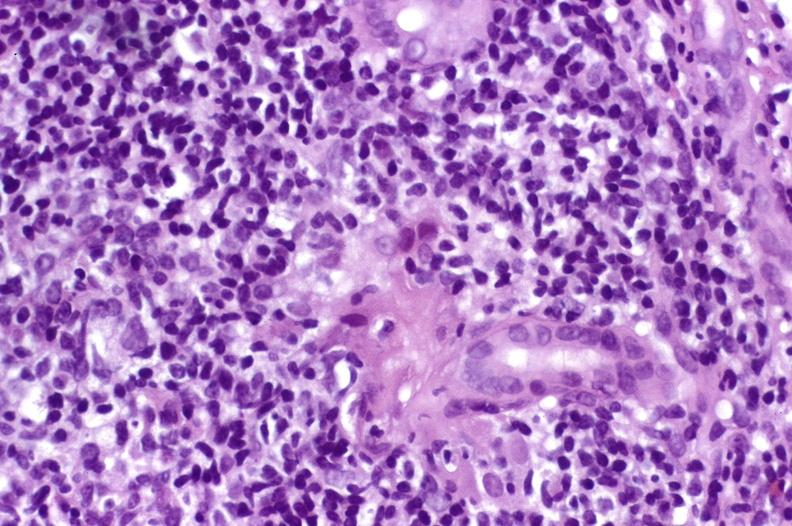what is present?
Answer the question using a single word or phrase. Hepatobiliary 